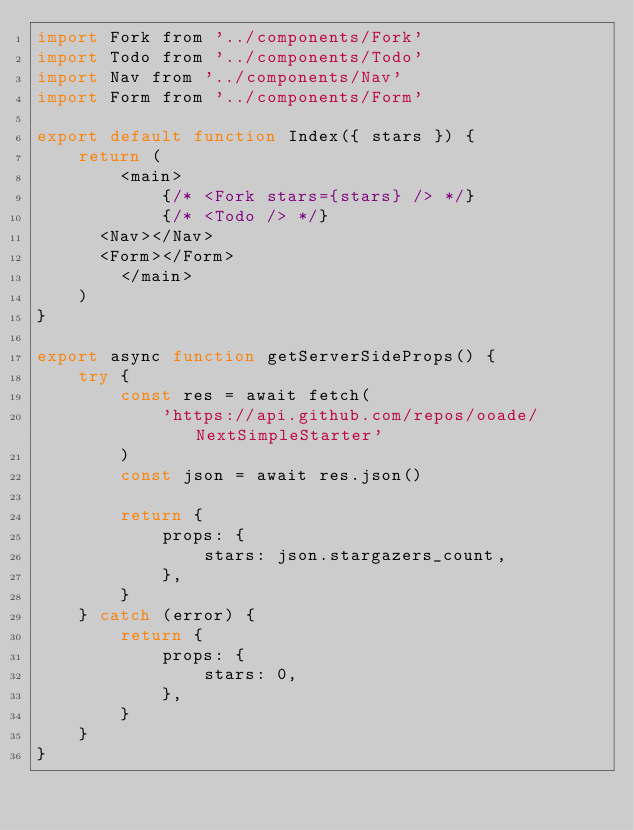Convert code to text. <code><loc_0><loc_0><loc_500><loc_500><_JavaScript_>import Fork from '../components/Fork'
import Todo from '../components/Todo'
import Nav from '../components/Nav'
import Form from '../components/Form'

export default function Index({ stars }) {
	return (
		<main>
			{/* <Fork stars={stars} /> */}
			{/* <Todo /> */}
      <Nav></Nav>
      <Form></Form>
		</main>
	)
}

export async function getServerSideProps() {
	try {
		const res = await fetch(
			'https://api.github.com/repos/ooade/NextSimpleStarter'
		)
		const json = await res.json()

		return {
			props: {
				stars: json.stargazers_count,
			},
		}
	} catch (error) {
		return {
			props: {
				stars: 0,
			},
		}
	}
}
</code> 